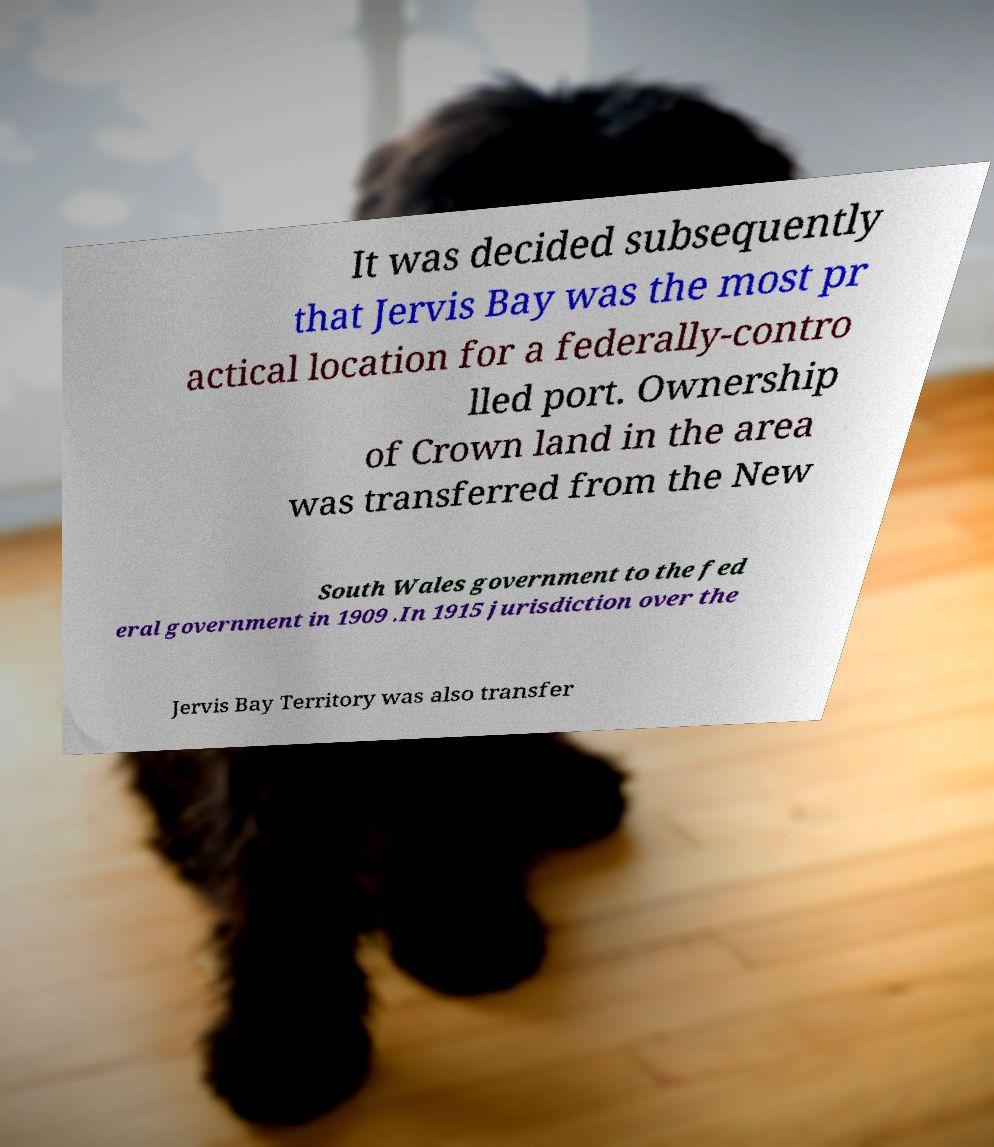For documentation purposes, I need the text within this image transcribed. Could you provide that? It was decided subsequently that Jervis Bay was the most pr actical location for a federally-contro lled port. Ownership of Crown land in the area was transferred from the New South Wales government to the fed eral government in 1909 .In 1915 jurisdiction over the Jervis Bay Territory was also transfer 